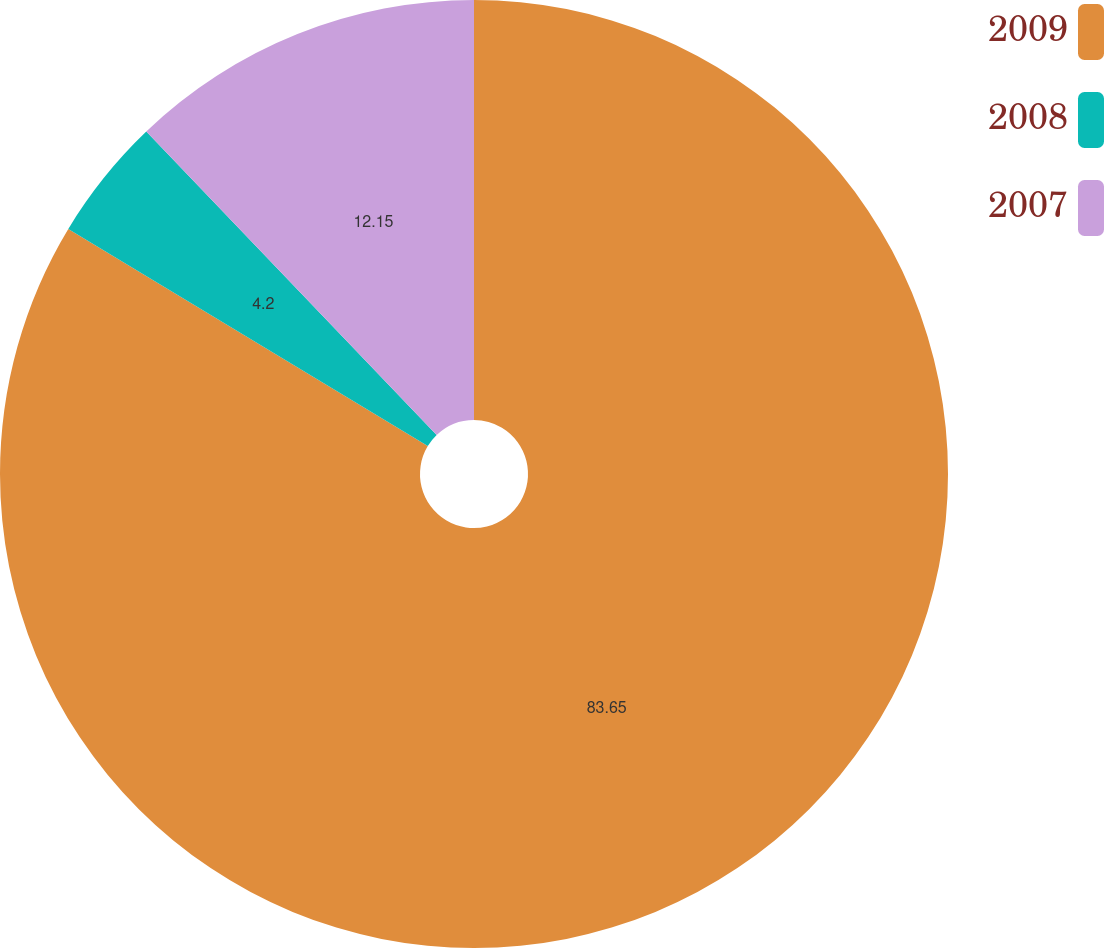<chart> <loc_0><loc_0><loc_500><loc_500><pie_chart><fcel>2009<fcel>2008<fcel>2007<nl><fcel>83.65%<fcel>4.2%<fcel>12.15%<nl></chart> 